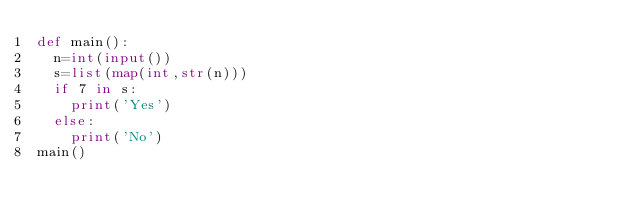Convert code to text. <code><loc_0><loc_0><loc_500><loc_500><_Python_>def main():
  n=int(input())
  s=list(map(int,str(n)))
  if 7 in s:
    print('Yes')
  else:
    print('No')
main()</code> 